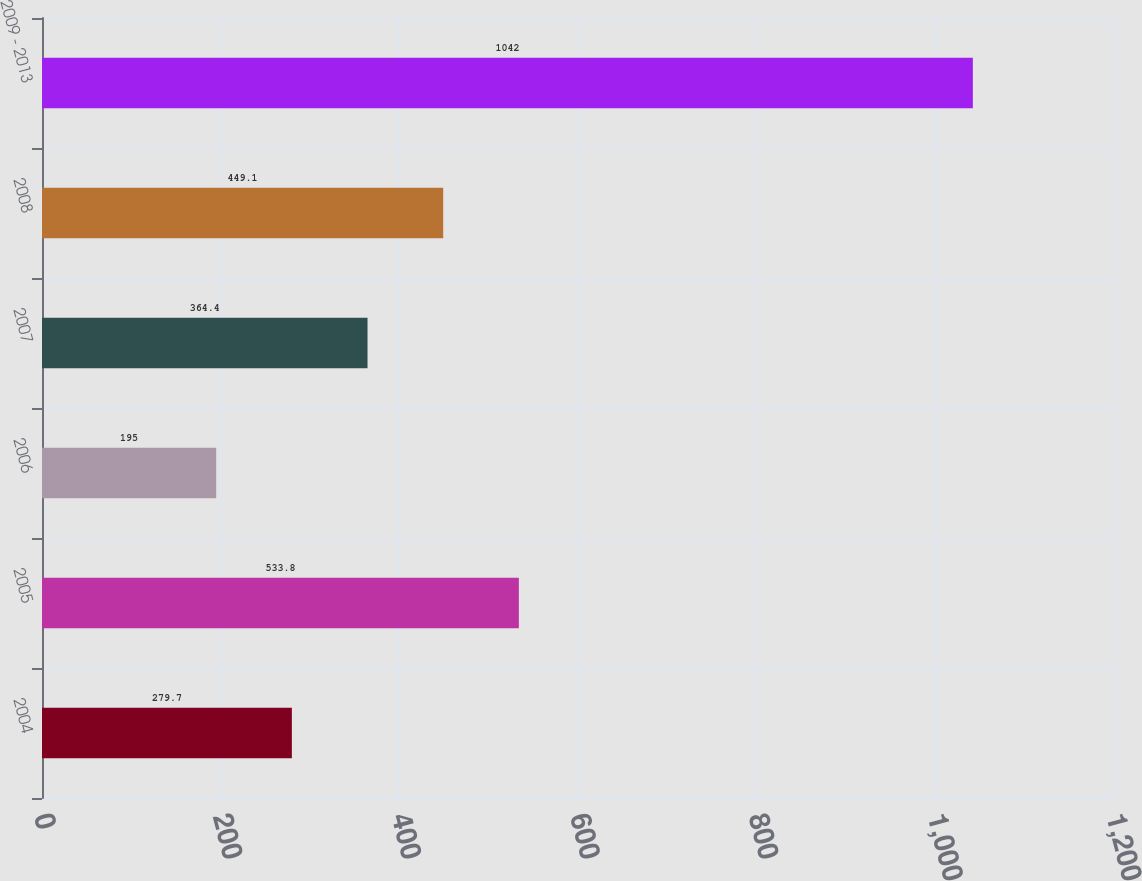Convert chart. <chart><loc_0><loc_0><loc_500><loc_500><bar_chart><fcel>2004<fcel>2005<fcel>2006<fcel>2007<fcel>2008<fcel>2009 - 2013<nl><fcel>279.7<fcel>533.8<fcel>195<fcel>364.4<fcel>449.1<fcel>1042<nl></chart> 